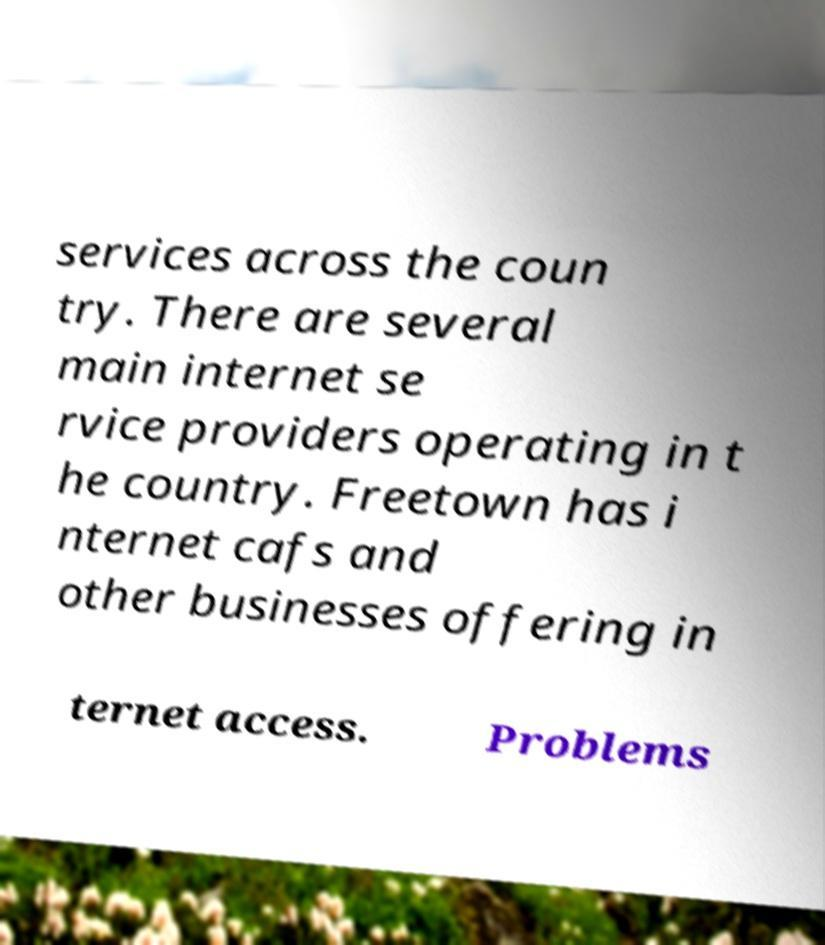What messages or text are displayed in this image? I need them in a readable, typed format. services across the coun try. There are several main internet se rvice providers operating in t he country. Freetown has i nternet cafs and other businesses offering in ternet access. Problems 